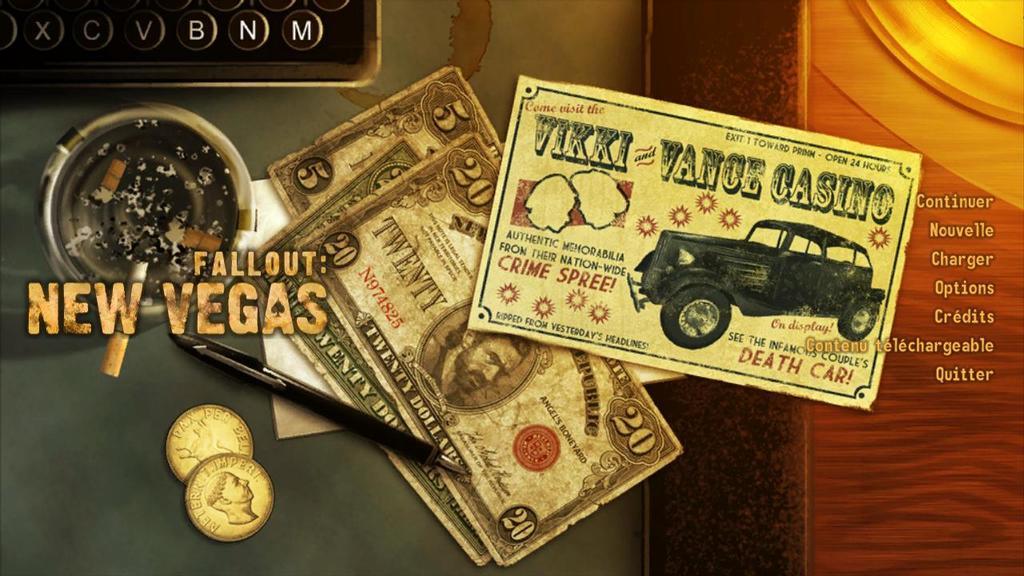What is the name of the fallout?
Make the answer very short. New vegas. How much is the top dollar bill worth?
Provide a short and direct response. 20. 